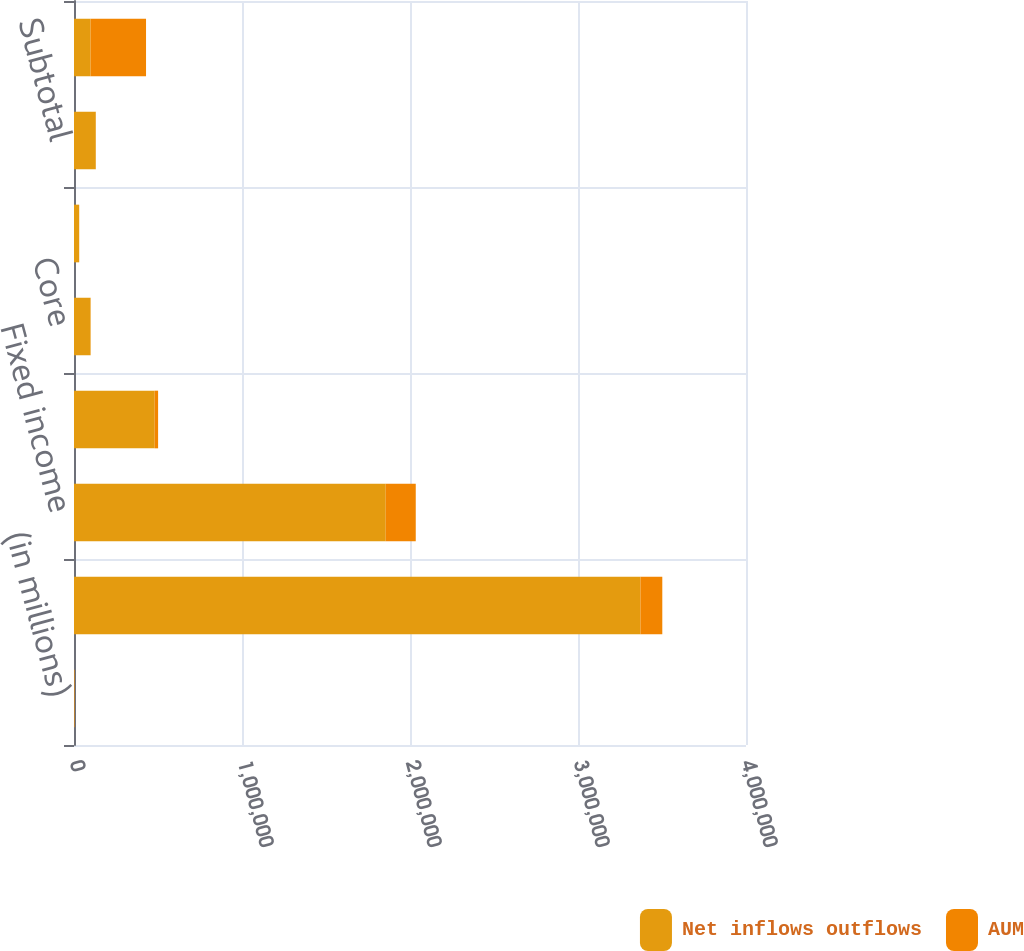<chart> <loc_0><loc_0><loc_500><loc_500><stacked_bar_chart><ecel><fcel>(in millions)<fcel>Equity<fcel>Fixed income<fcel>Multi-asset<fcel>Core<fcel>Currency and commodities (2)<fcel>Subtotal<fcel>Long-term<nl><fcel>Net inflows outflows<fcel>2017<fcel>3.37164e+06<fcel>1.85546e+06<fcel>480278<fcel>98533<fcel>30814<fcel>129347<fcel>98533<nl><fcel>AUM<fcel>2017<fcel>130146<fcel>178787<fcel>20330<fcel>780<fcel>197<fcel>977<fcel>330240<nl></chart> 